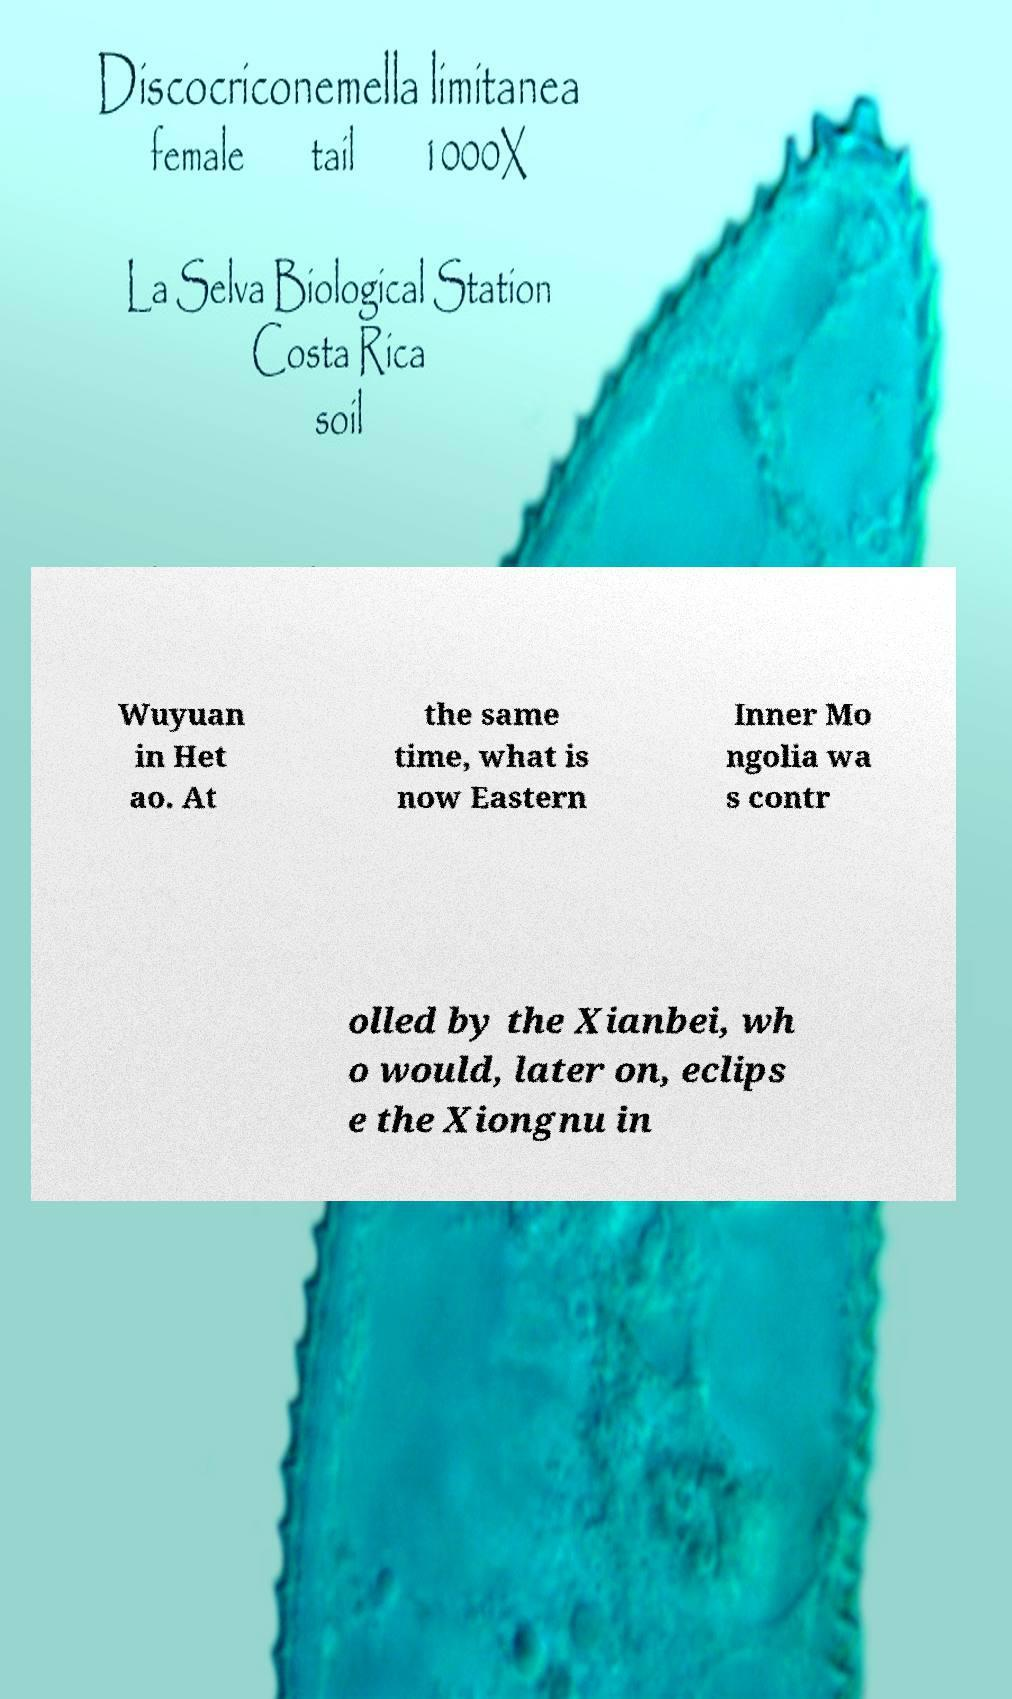What messages or text are displayed in this image? I need them in a readable, typed format. Wuyuan in Het ao. At the same time, what is now Eastern Inner Mo ngolia wa s contr olled by the Xianbei, wh o would, later on, eclips e the Xiongnu in 